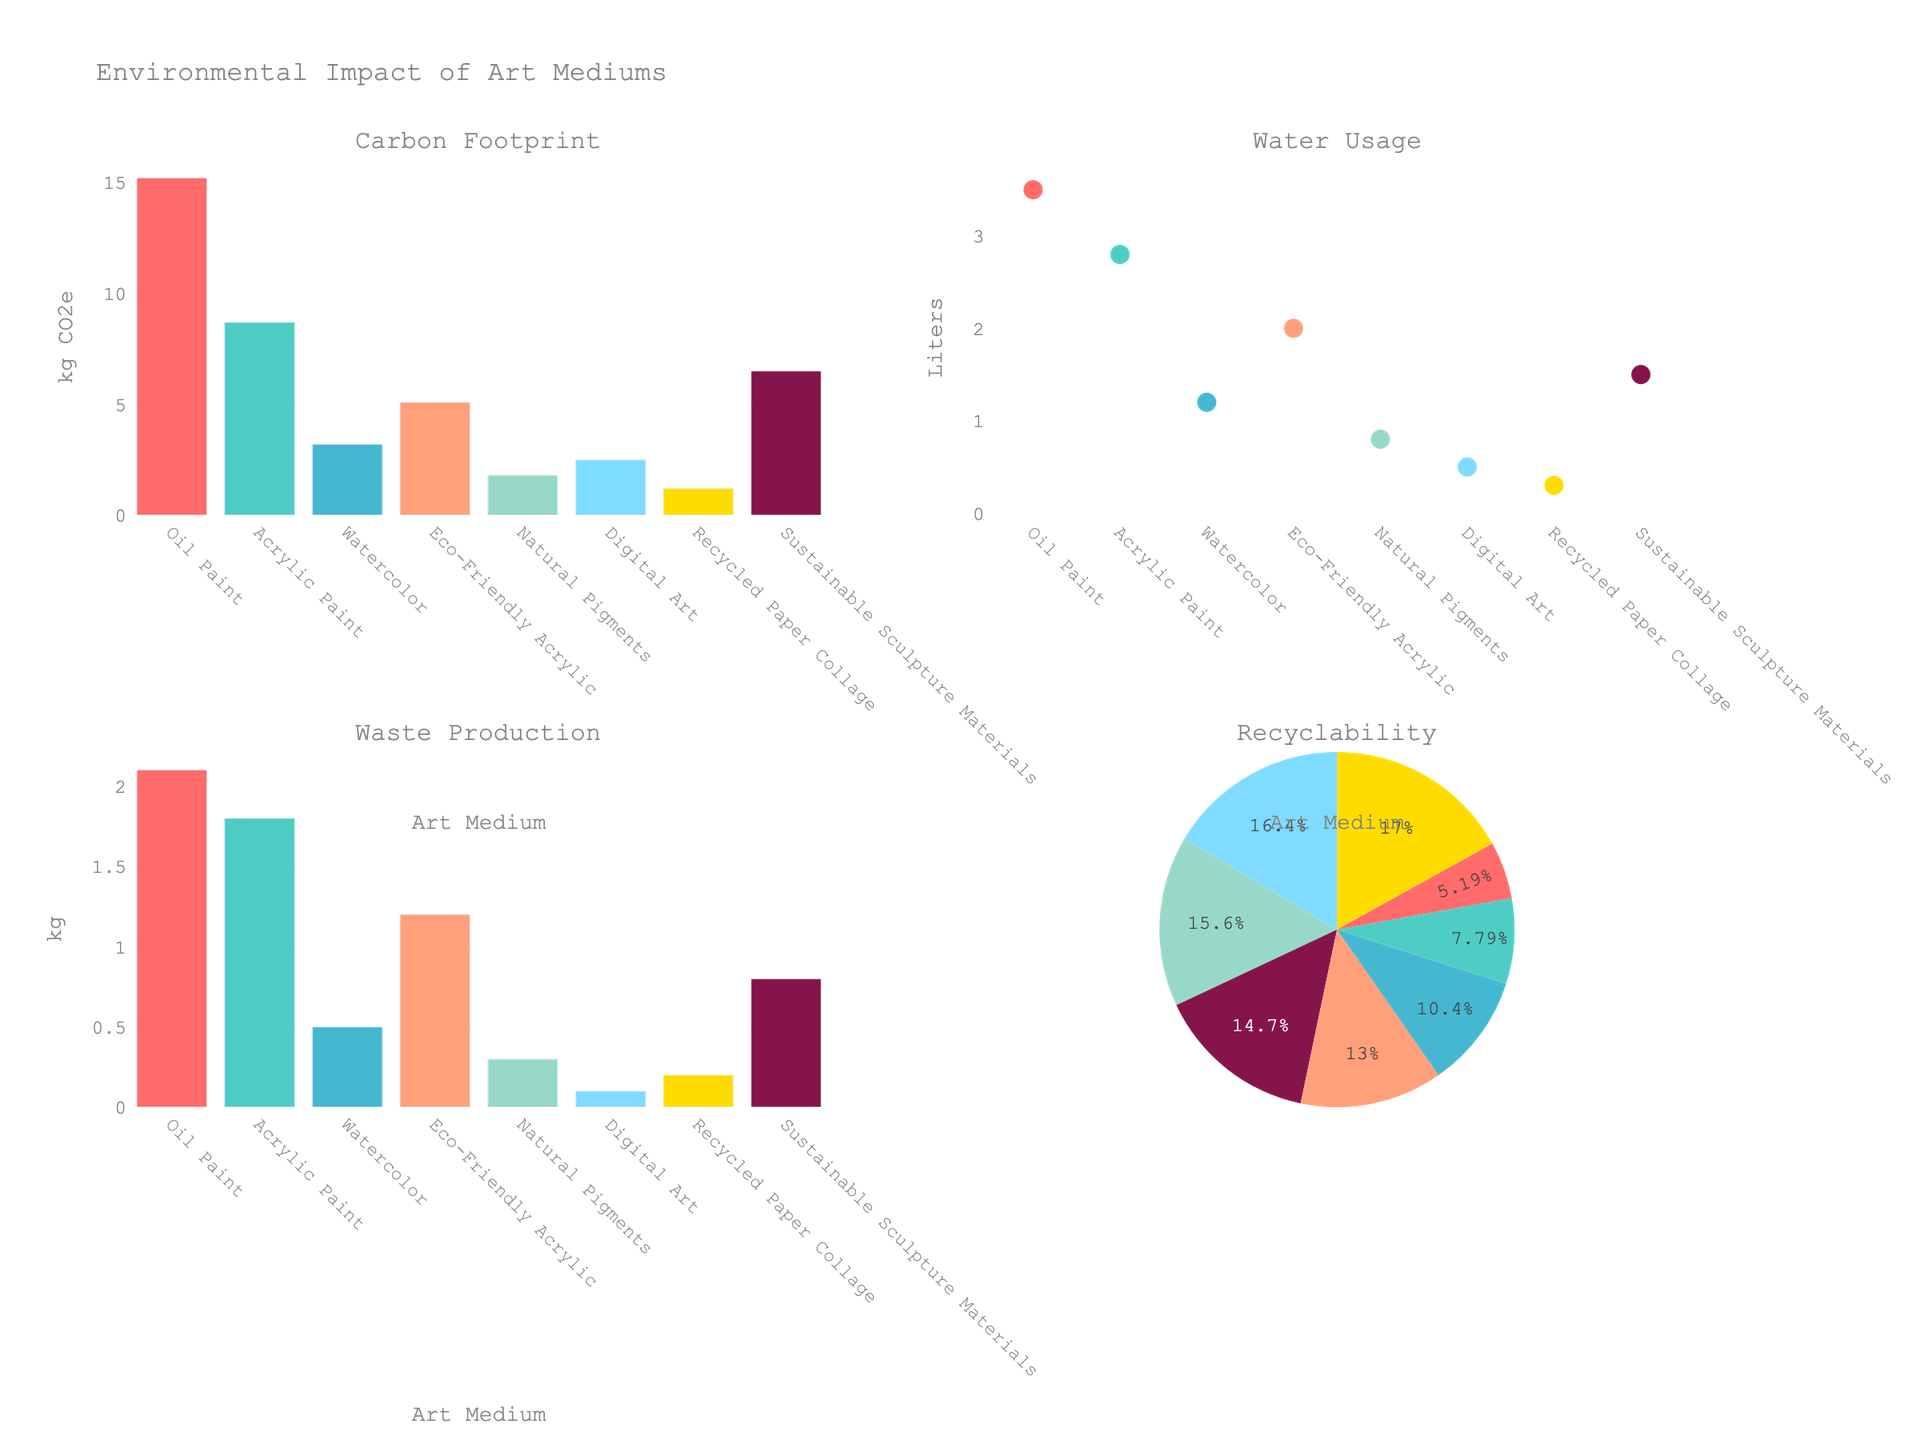How does the Satisfaction Score differ between Chain Stores and Independent Stores for the 18-30 age group with low income? For the 18-30 age group with low income, the bars represent different values. The Chain Store has a Satisfaction Score of 5.2, while the Independent Store has a Satisfaction Score of 7.5. Therefore, the Satisfaction Score for Independent Stores is higher by 2.3 points.
Answer: Independent Stores score higher by 2.3 points Which age group shows the highest Satisfaction Score for Chain Stores with high income? By examining the bars for Chain Stores with high income across age groups, we see the Satisfaction Scores as follows: 6.8 for 18-30, 7.0 for 31-50, and 7.2 for 51+. Thus, the 51+ age group has the highest Satisfaction Score for high income in Chain Stores.
Answer: 51+ What is the average Satisfaction Score for Independent Stores across all age groups with medium income? The medium income Satisfaction Scores for Independent Stores are 8.2 for 18-30, 8.5 for 31-50, and 8.7 for 51+. Summing these values (8.2 + 8.5 + 8.7) = 25.4, and then dividing by the number of data points (3) gives an average of 8.47.
Answer: 8.47 Which store type generally performs better across all demographics in terms of Satisfaction Score? By looking at the fig, it is evident that Independent Stores consistently have higher Satisfaction Scores across all demographics compared to Chain Stores. This pattern is observed in all age groups and income levels.
Answer: Independent Stores How much greater is the Satisfaction Score for Independent Stores over Chain Stores for the 31-50 age group with low income? The Satisfaction Scores for the 31-50 age group with low income are 7.8 for Independent Stores and 5.5 for Chain Stores. Subtracting the Chain Store score from the Independent Store score gives 7.8 - 5.5 = 2.3.
Answer: 2.3 What is the Satisfaction Score for Chain Stores among the 51+ age group with medium income? To find this, we look at the bar representing the 51+ age group with medium income under Chain Stores, which has a Satisfaction Score of 6.7.
Answer: 6.7 Which store type has the highest Satisfaction Score for any demographic, and what is that score? The highest Satisfaction Score for any demographic is for Independent Stores with high income in the 51+ age group, which is 9.2.
Answer: Independent Stores, 9.2 Compare the Satisfaction Scores for the 18-30 age group between medium and high income levels for Chain Stores. For Chain Stores in the 18-30 age group, the Satisfaction Score for medium income is 6.1 and for high income is 6.8. The difference between them is 6.8 - 6.1 = 0.7.
Answer: 0.7 